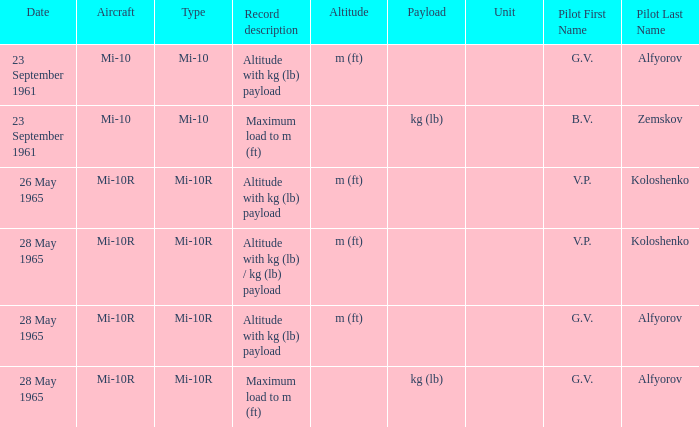Date of 23 september 1961, and a Pilot of b.v. zemskov had what record description? Maximum load to m (ft). 